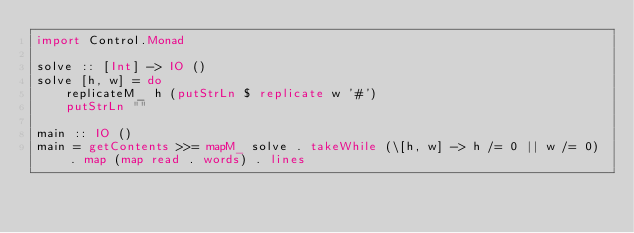Convert code to text. <code><loc_0><loc_0><loc_500><loc_500><_Haskell_>import Control.Monad

solve :: [Int] -> IO ()
solve [h, w] = do
    replicateM_ h (putStrLn $ replicate w '#')
    putStrLn ""

main :: IO ()
main = getContents >>= mapM_ solve . takeWhile (\[h, w] -> h /= 0 || w /= 0) . map (map read . words) . lines</code> 